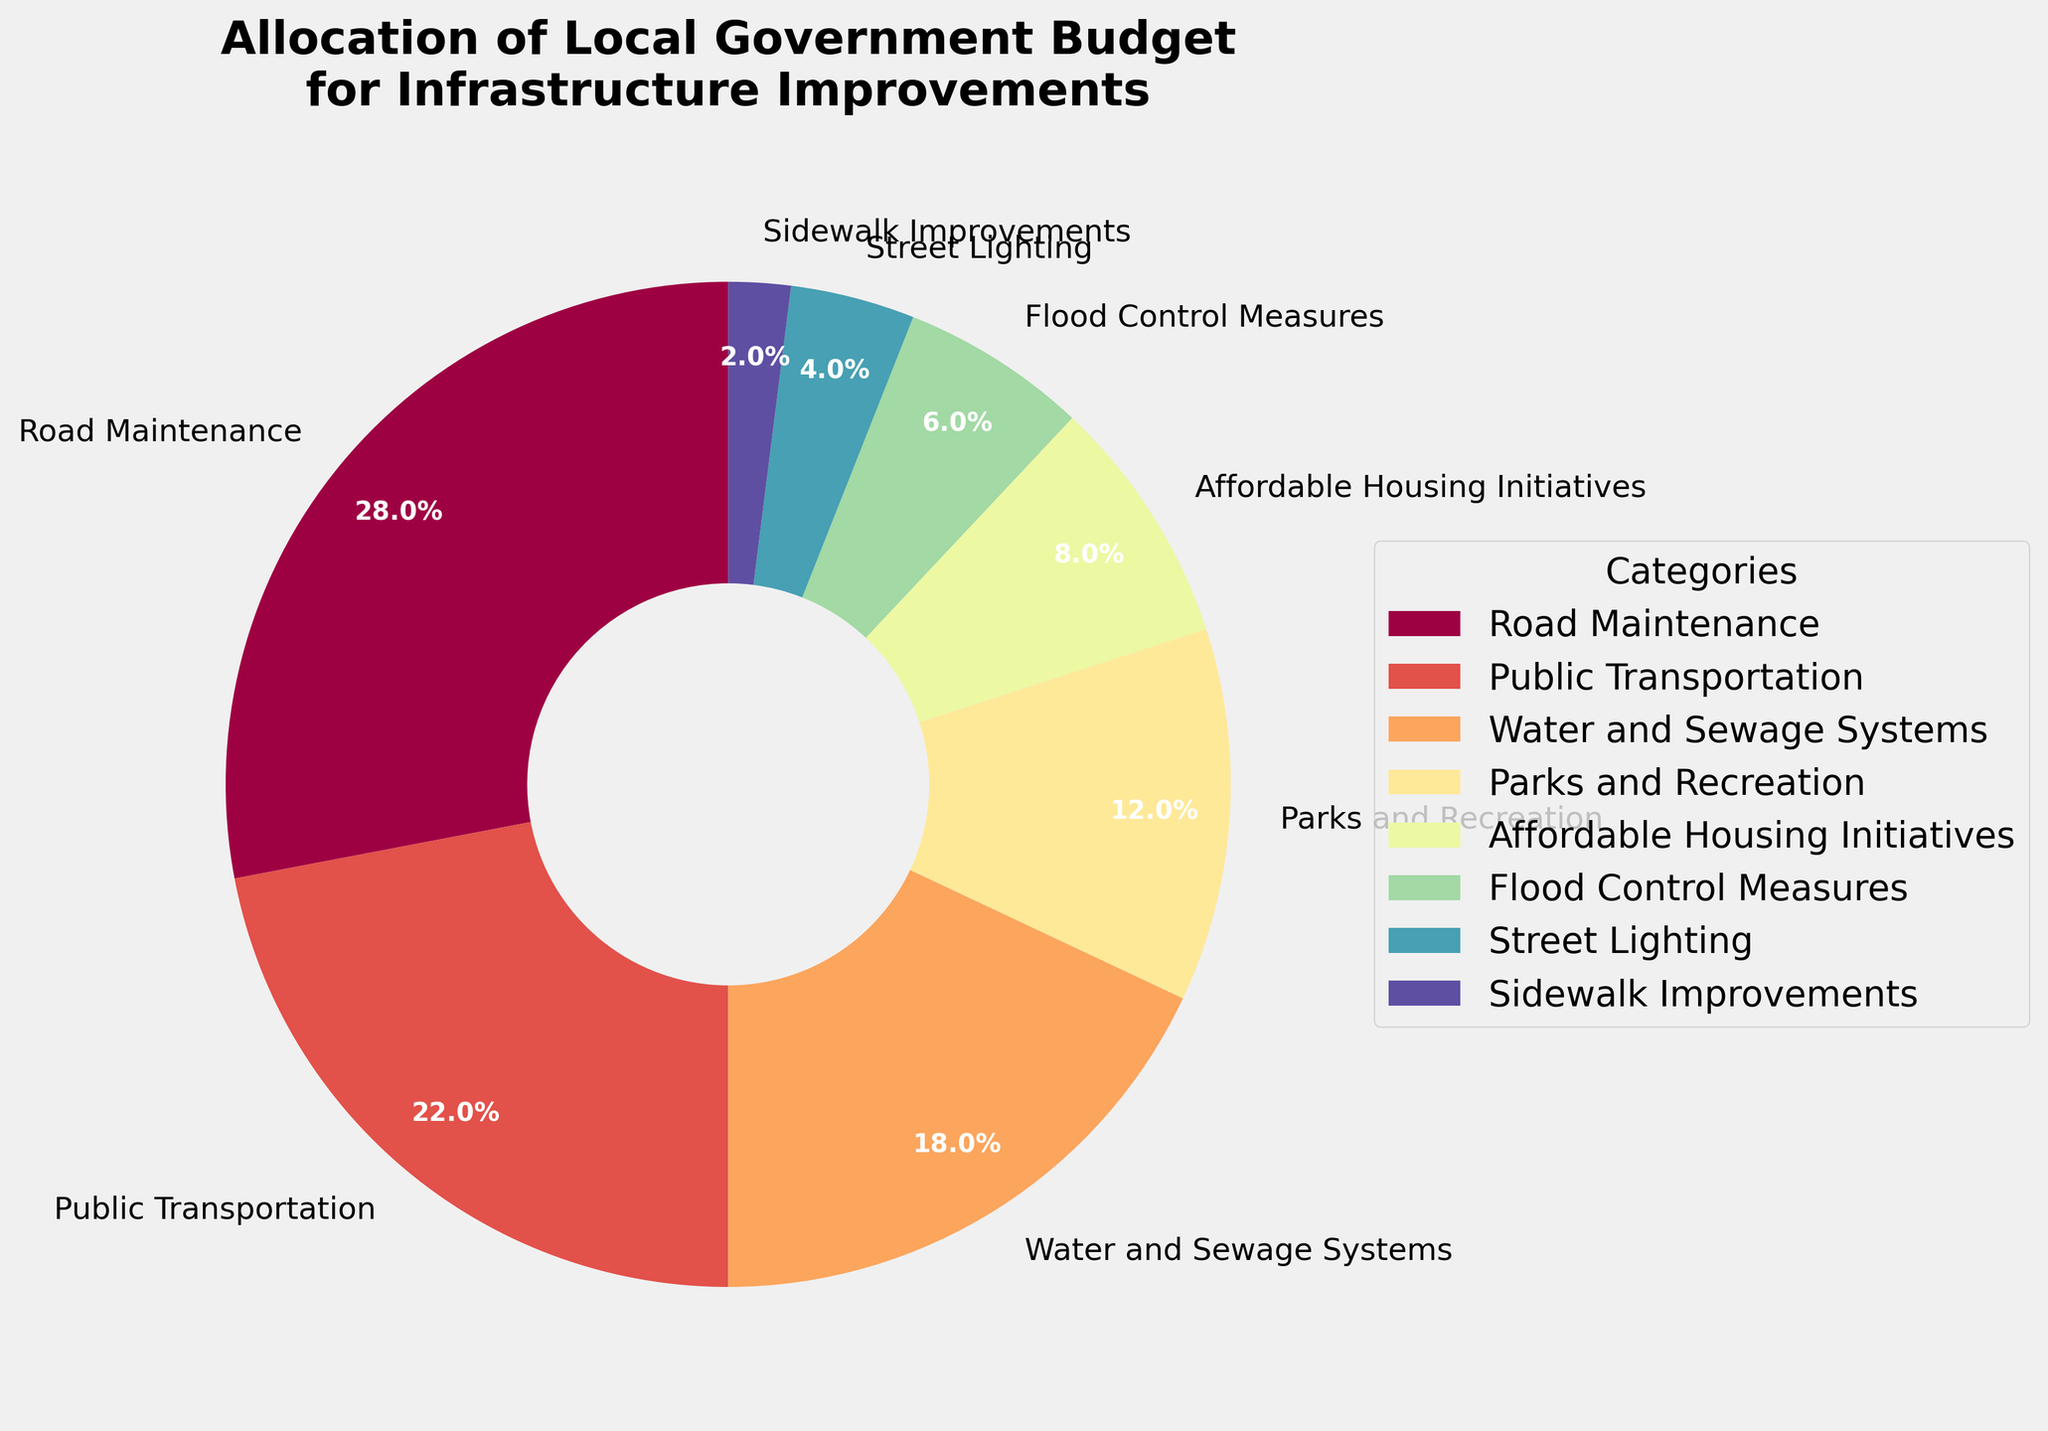What is the percentage of the budget allocated to Road Maintenance? The pie chart indicates the percentage of the budget allocated to each category. Road Maintenance is labeled with its respective percentage.
Answer: 28% Which category has the smallest allocation and what is the percentage? By examining the pie chart, we can see that Sidewalk Improvements has the smallest slice, which is labeled with its percentage.
Answer: Sidewalk Improvements, 2% What is the combined budget allocation for Parks and Recreation and Public Transportation? To find the combined budget allocation, we add the percentage for Parks and Recreation (12%) to that for Public Transportation (22%). 12% + 22% = 34%
Answer: 34% Which categories combined have a budget allocation greater than that of Road Maintenance? Compare the sum of different combinations of other categories with Road Maintenance. Public Transportation (22%) + Water and Sewage Systems (18%) = 40%, which is greater than Road Maintenance (28%).
Answer: Public Transportation and Water and Sewage Systems Does the budget for Affordable Housing Initiatives and Flood Control Measures together exceed the budget for Parks and Recreation? Add the percentages for Affordable Housing Initiatives (8%) and Flood Control Measures (6%) and compare with Parks and Recreation (12%). 8% + 6% = 14%, which exceeds 12%.
Answer: Yes Which categories have a budget allocation less than 10%? Identify the slices on the pie chart that are labeled with percentages less than 10%. Affordable Housing Initiatives (8%), Flood Control Measures (6%), Street Lighting (4%), and Sidewalk Improvements (2%) are all less than 10%.
Answer: Affordable Housing Initiatives, Flood Control Measures, Street Lighting, Sidewalk Improvements How much more budget is allocated to Water and Sewage Systems than to Street Lighting? Subtract the percentage allocated to Street Lighting (4%) from the percentage allocated to Water and Sewage Systems (18%). 18% - 4% = 14%
Answer: 14% By how much does the budget allocation for Road Maintenance exceed that for Flood Control Measures? Subtract the percentage allocated to Flood Control Measures (6%) from the percentage allocated to Road Maintenance (28%). 28% - 6% = 22%
Answer: 22% How many categories have budget allocations between 10% and 20% inclusive? Identify and count the slices on the pie chart that are labeled with percentages within this range. There are two such categories: Water and Sewage Systems (18%) and Parks and Recreation (12%).
Answer: 2 Which category has the second-largest budget allocation, and what is its percentage? Finding the second-largest slice by visual comparison, we see that Public Transportation follows Road Maintenance. Its percentage is labeled on the chart.
Answer: Public Transportation, 22% 